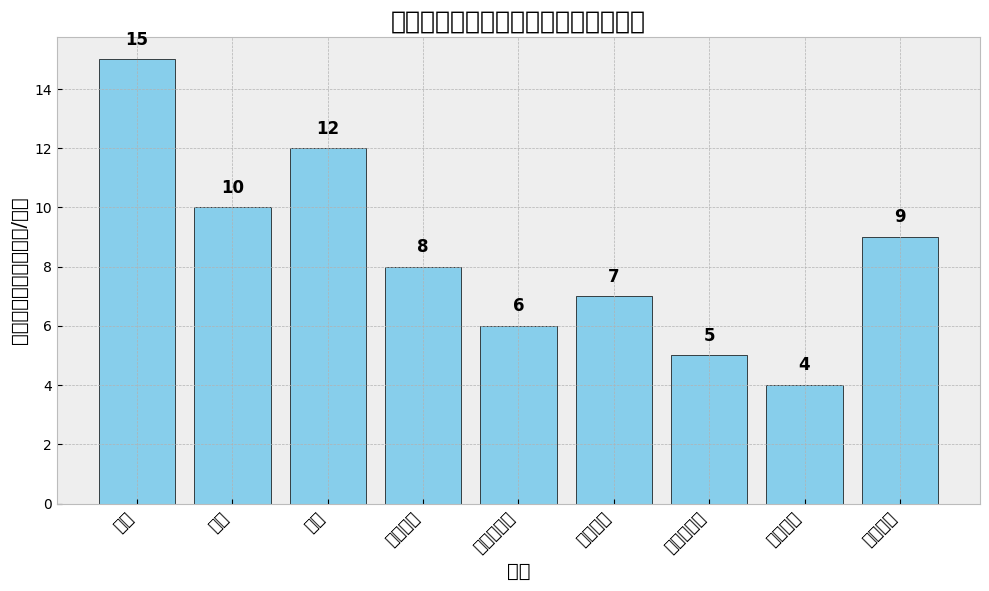What's the most frequently used application scenario for foldable smartphones? The figure shows the usage frequencies for various scenarios. The highest bar represents "阅读" with 15 hours per week.
Answer: 阅读 How many hours per week do users spend on "社交媒体" and "游戏" combined? The bar for "社交媒体" shows 9 hours, and the bar for "游戏" shows 10 hours. Adding these together gives 9 + 10 = 19 hours.
Answer: 19 Which has a lower usage frequency: "多任务处理" or "媒体播放"? The bars for "多任务处理" and "媒体播放" show 6 and 7 hours, respectively. Comparing them, 6 is less than 7.
Answer: 多任务处理 What is the difference in usage frequency between "游戏" and "办公"? The bar for "游戏" shows 10 hours, and the bar for "办公" shows 12 hours. The difference is 12 - 10 = 2 hours.
Answer: 2 What is the least frequently used application scenario? The shortest bar represents "在线购物" with 4 hours per week.
Answer: 在线购物 Compare the usage frequencies of "视频会议" and "媒体播放." Which one is higher and by how much? "视频会议" shows 8 hours, and "媒体播放" shows 7 hours. "视频会议" is higher by 8 - 7 = 1 hour.
Answer: 视频会议, 1 If users were to spend an additional 2 hours per week on "拍照和录像," what would the new usage frequency be? The current frequency for "拍照和录像" is 5 hours. Adding 2 more hours gives 5 + 2 = 7 hours.
Answer: 7 Out of "阅读," "社交媒体," and "媒体播放," which scenario is used the second-most frequently? The bars show "阅读" at 15 hours, "社交媒体" at 9 hours, and "媒体播放" at 7 hours. The second-highest among these is "社交媒体."
Answer: 社交媒体 What is the total usage frequency across all application scenarios? Sum the hours for each scenario: 15 + 10 + 12 + 8 + 6 + 7 + 5 + 4 + 9 = 76 hours.
Answer: 76 Which scenario shows a usage frequency equal to the median of all data points? The data points are: 15, 10, 12, 8, 6, 7, 5, 4, and 9. Ordering them gives 4, 5, 6, 7, 8, 9, 10, 12, 15. The median value, being the middle value, is 8. Hence, "视频会议" matches the median.
Answer: 视频会议 